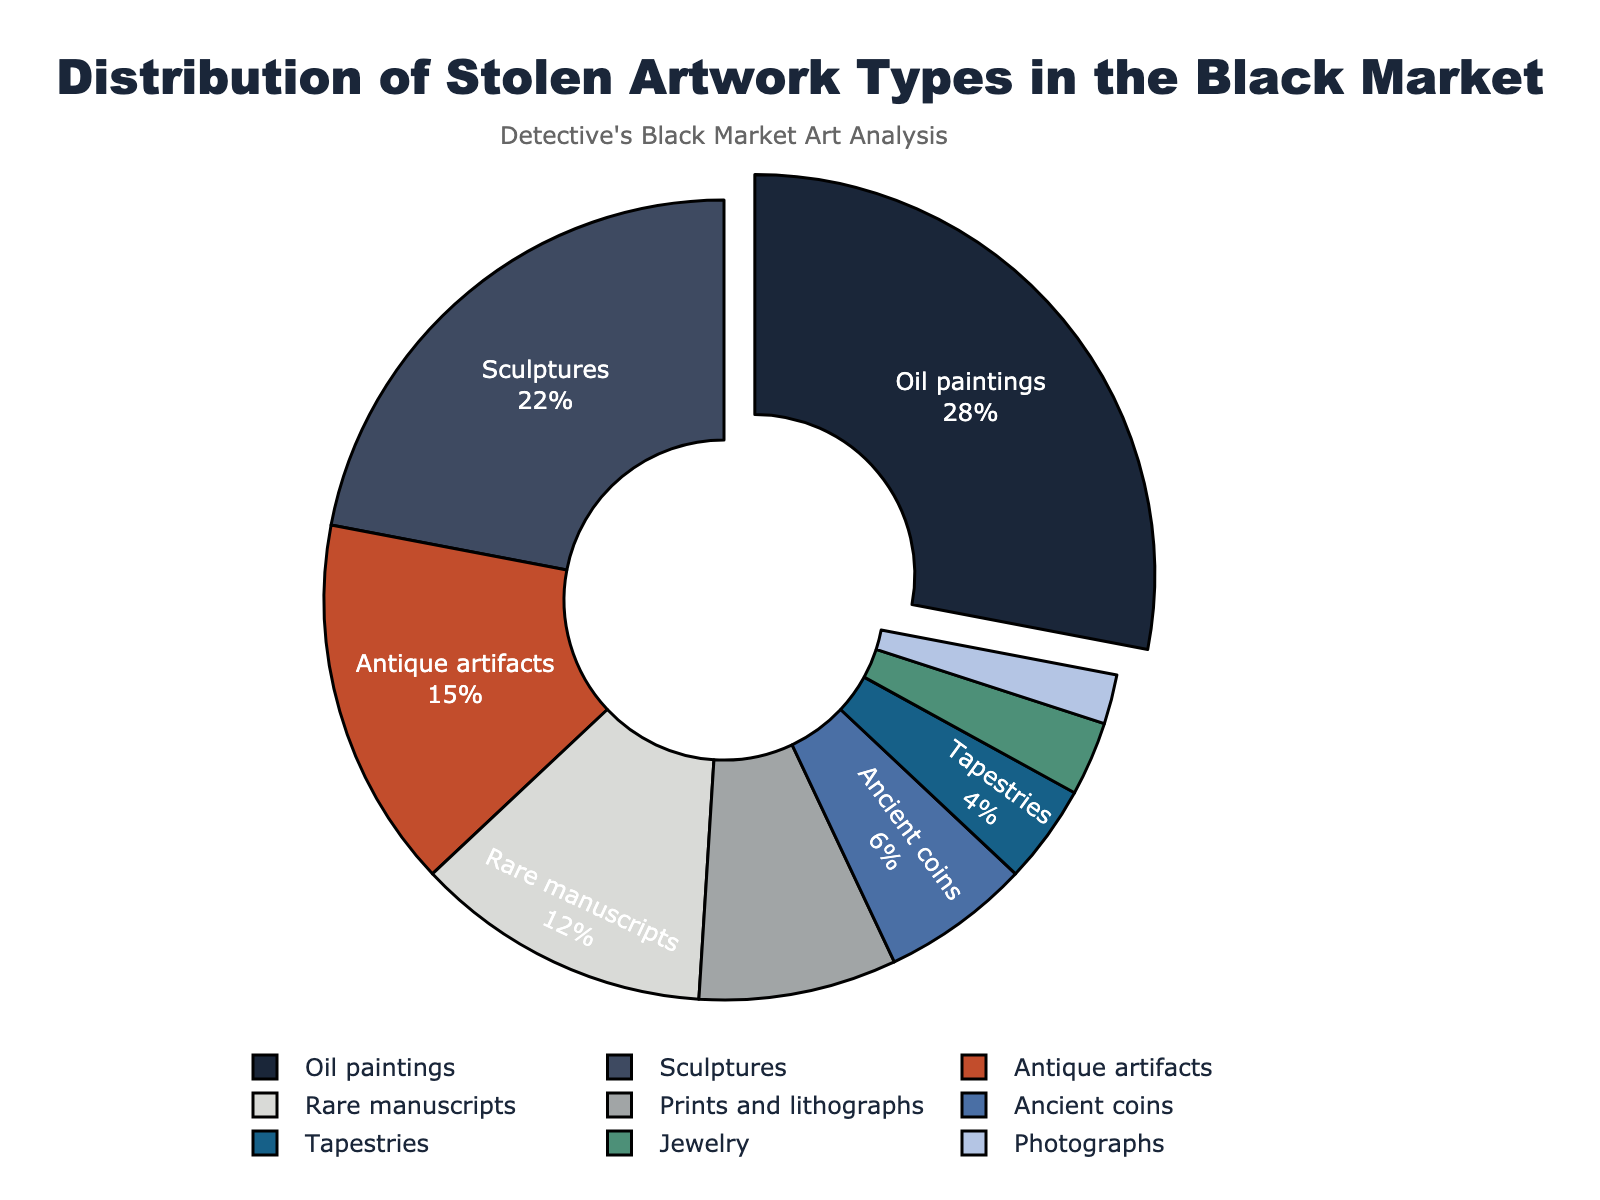what is the most common type of stolen artwork in the black market? The most common type is the one with the highest percentage. Referring to the pie chart, Oil paintings have the highest slice pulled out.
Answer: Oil paintings what is the combined percentage of Sculptures and Rare manuscripts? Add the percentages of Sculptures (22%) and Rare manuscripts (12%). 22 + 12 = 34
Answer: 34% which category has a smaller percentage of stolen art: Jewelry or Ancient coins? Compare the percentages of Jewelry (3%) and Ancient coins (6%). Jewelry has a smaller percentage.
Answer: Jewelry how do Oil paintings compare visually to Tapestries in terms of size? Oil paintings have a much larger portion of the pie chart than Tapestries.
Answer: Oil paintings are larger what proportion of stolen artworks do Sculptures and Antique artifacts make up combined? Add the percentages of Sculptures (22%) and Antique artifacts (15%), then convert to a fraction. 22 + 15 = 37%. 37/100 = 0.37
Answer: 0.37 what artwork type has the least representation in the black market? The artwork type with the smallest slice is the least represented. Photographs have the smallest portion.
Answer: Photographs compare the sum of percentages of Ancient coins and Tapestries to Sculptures Add the percentages of Ancient coins (6%) and Tapestries (4%) which equals 10%, compare this to Sculptures (22%). 10 < 22
Answer: Less than Sculptures what is the difference in percentages between Rare manuscripts and Prints and lithographs? Subtract the percentage of Prints and lithographs (8%) from Rare manuscripts (12%). 12 - 8 = 4
Answer: 4% what type of stolen artwork is represented by the blue color in the pie chart? Identify the slice colored blue in the pie chart, which corresponds to the label Tapestries.
Answer: Tapestries compare the categories of Antique artifacts and Rare manuscripts in terms of visual representation Antique artifacts take up a larger portion of the pie chart compared to Rare manuscripts.
Answer: Antique artifacts are larger 